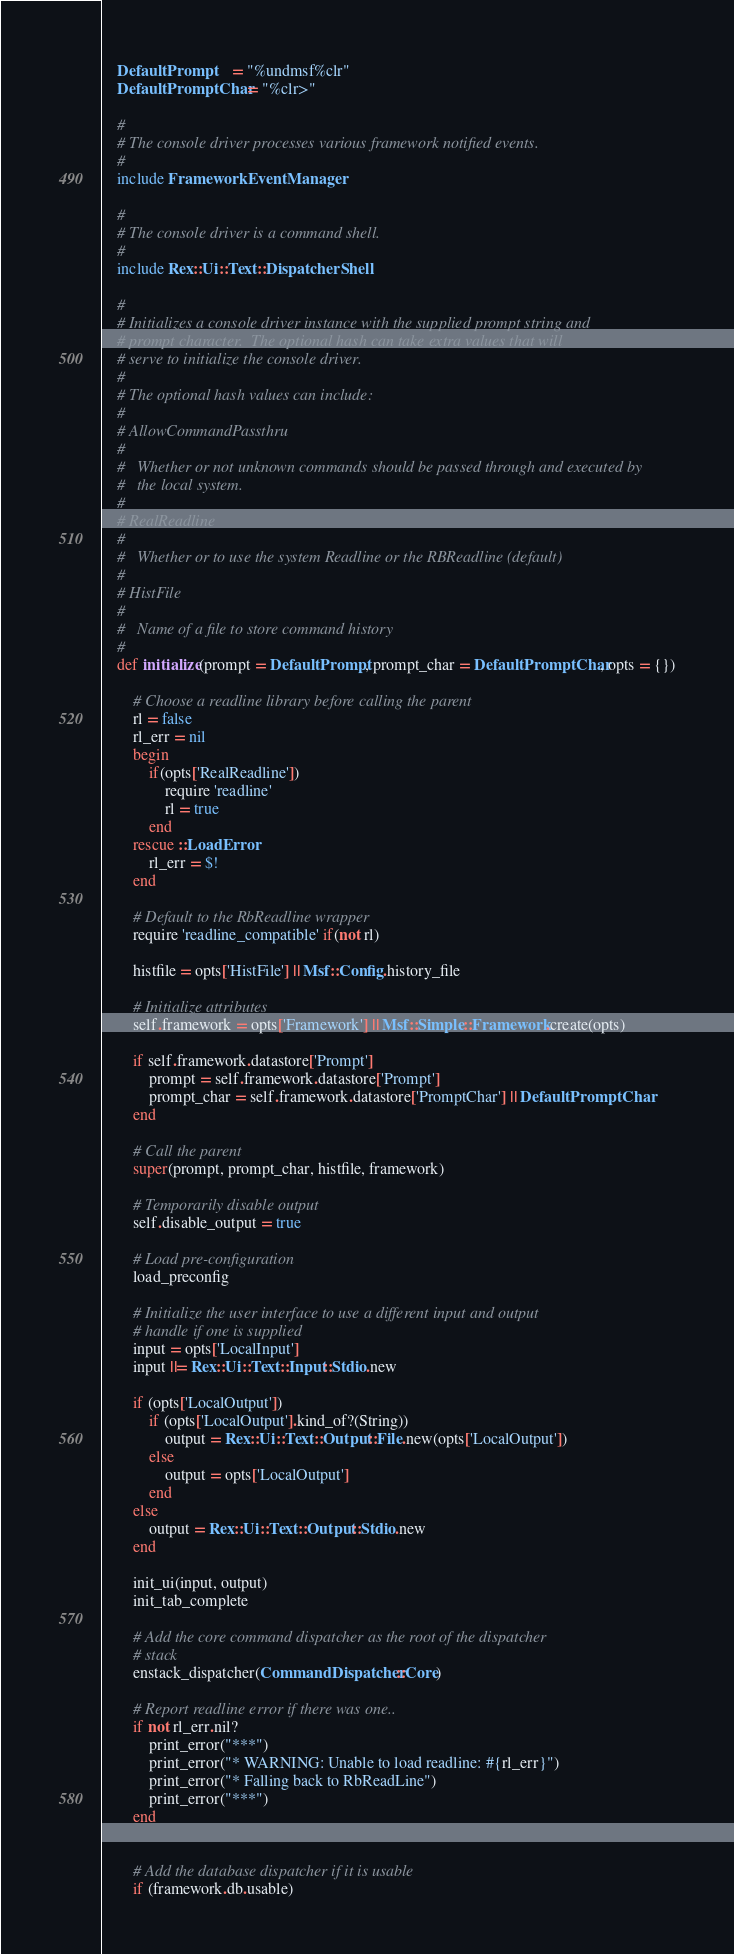<code> <loc_0><loc_0><loc_500><loc_500><_Ruby_>
	DefaultPrompt     = "%undmsf%clr"
	DefaultPromptChar = "%clr>"

	#
	# The console driver processes various framework notified events.
	#
	include FrameworkEventManager

	#
	# The console driver is a command shell.
	#
	include Rex::Ui::Text::DispatcherShell

	#
	# Initializes a console driver instance with the supplied prompt string and
	# prompt character.  The optional hash can take extra values that will
	# serve to initialize the console driver.
	#
	# The optional hash values can include:
	#
	# AllowCommandPassthru
	#
	# 	Whether or not unknown commands should be passed through and executed by
	# 	the local system.
	#
	# RealReadline
	#
	# 	Whether or to use the system Readline or the RBReadline (default)
	#
	# HistFile
	#
	#	Name of a file to store command history
	#
	def initialize(prompt = DefaultPrompt, prompt_char = DefaultPromptChar, opts = {})

		# Choose a readline library before calling the parent
		rl = false
		rl_err = nil
		begin
			if(opts['RealReadline'])
				require 'readline'
				rl = true
			end
		rescue ::LoadError
			rl_err = $!
		end

		# Default to the RbReadline wrapper
		require 'readline_compatible' if(not rl)

		histfile = opts['HistFile'] || Msf::Config.history_file

		# Initialize attributes
		self.framework = opts['Framework'] || Msf::Simple::Framework.create(opts)

		if self.framework.datastore['Prompt']
			prompt = self.framework.datastore['Prompt']
			prompt_char = self.framework.datastore['PromptChar'] || DefaultPromptChar
		end

		# Call the parent
		super(prompt, prompt_char, histfile, framework)

		# Temporarily disable output
		self.disable_output = true

		# Load pre-configuration
		load_preconfig

		# Initialize the user interface to use a different input and output
		# handle if one is supplied
		input = opts['LocalInput']
		input ||= Rex::Ui::Text::Input::Stdio.new

		if (opts['LocalOutput'])
			if (opts['LocalOutput'].kind_of?(String))
				output = Rex::Ui::Text::Output::File.new(opts['LocalOutput'])
			else
				output = opts['LocalOutput']
			end
		else
			output = Rex::Ui::Text::Output::Stdio.new
		end

		init_ui(input, output)
		init_tab_complete

		# Add the core command dispatcher as the root of the dispatcher
		# stack
		enstack_dispatcher(CommandDispatcher::Core)

		# Report readline error if there was one..
		if not rl_err.nil?
			print_error("***")
			print_error("* WARNING: Unable to load readline: #{rl_err}")
			print_error("* Falling back to RbReadLine")
			print_error("***")
		end


		# Add the database dispatcher if it is usable
		if (framework.db.usable)</code> 